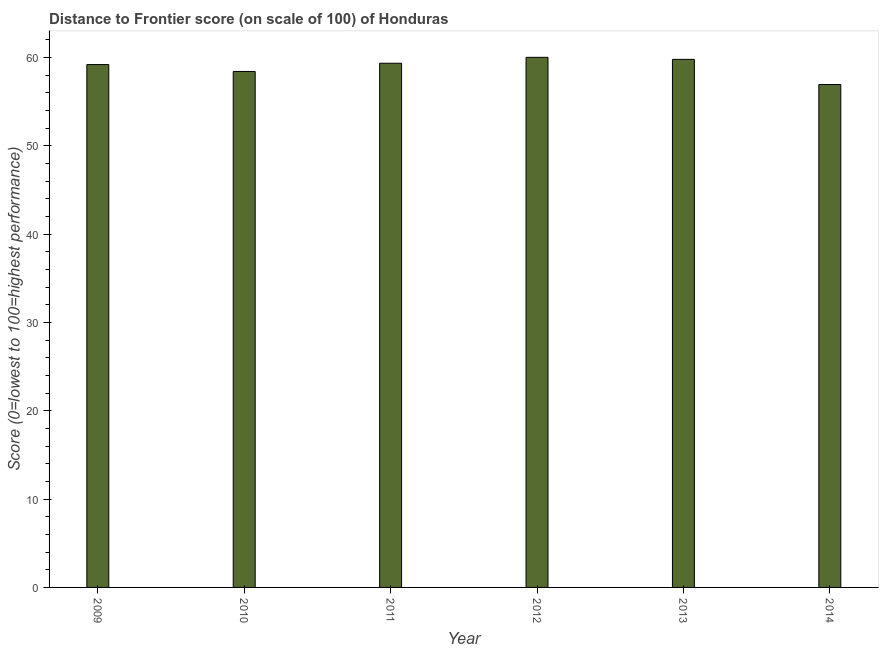Does the graph contain grids?
Your answer should be compact. No. What is the title of the graph?
Your answer should be compact. Distance to Frontier score (on scale of 100) of Honduras. What is the label or title of the Y-axis?
Your answer should be very brief. Score (0=lowest to 100=highest performance). What is the distance to frontier score in 2013?
Ensure brevity in your answer.  59.8. Across all years, what is the maximum distance to frontier score?
Your answer should be very brief. 60.03. Across all years, what is the minimum distance to frontier score?
Keep it short and to the point. 56.95. In which year was the distance to frontier score minimum?
Provide a short and direct response. 2014. What is the sum of the distance to frontier score?
Provide a succinct answer. 353.78. What is the difference between the distance to frontier score in 2009 and 2010?
Provide a short and direct response. 0.78. What is the average distance to frontier score per year?
Keep it short and to the point. 58.96. What is the median distance to frontier score?
Your answer should be compact. 59.28. In how many years, is the distance to frontier score greater than 14 ?
Keep it short and to the point. 6. Is the distance to frontier score in 2011 less than that in 2014?
Provide a succinct answer. No. What is the difference between the highest and the second highest distance to frontier score?
Your answer should be very brief. 0.23. What is the difference between the highest and the lowest distance to frontier score?
Keep it short and to the point. 3.08. How many bars are there?
Ensure brevity in your answer.  6. What is the difference between two consecutive major ticks on the Y-axis?
Keep it short and to the point. 10. Are the values on the major ticks of Y-axis written in scientific E-notation?
Give a very brief answer. No. What is the Score (0=lowest to 100=highest performance) of 2009?
Make the answer very short. 59.21. What is the Score (0=lowest to 100=highest performance) in 2010?
Offer a very short reply. 58.43. What is the Score (0=lowest to 100=highest performance) of 2011?
Keep it short and to the point. 59.36. What is the Score (0=lowest to 100=highest performance) of 2012?
Keep it short and to the point. 60.03. What is the Score (0=lowest to 100=highest performance) in 2013?
Offer a terse response. 59.8. What is the Score (0=lowest to 100=highest performance) in 2014?
Make the answer very short. 56.95. What is the difference between the Score (0=lowest to 100=highest performance) in 2009 and 2010?
Keep it short and to the point. 0.78. What is the difference between the Score (0=lowest to 100=highest performance) in 2009 and 2012?
Your answer should be compact. -0.82. What is the difference between the Score (0=lowest to 100=highest performance) in 2009 and 2013?
Your response must be concise. -0.59. What is the difference between the Score (0=lowest to 100=highest performance) in 2009 and 2014?
Offer a terse response. 2.26. What is the difference between the Score (0=lowest to 100=highest performance) in 2010 and 2011?
Your answer should be compact. -0.93. What is the difference between the Score (0=lowest to 100=highest performance) in 2010 and 2012?
Your response must be concise. -1.6. What is the difference between the Score (0=lowest to 100=highest performance) in 2010 and 2013?
Keep it short and to the point. -1.37. What is the difference between the Score (0=lowest to 100=highest performance) in 2010 and 2014?
Your response must be concise. 1.48. What is the difference between the Score (0=lowest to 100=highest performance) in 2011 and 2012?
Provide a short and direct response. -0.67. What is the difference between the Score (0=lowest to 100=highest performance) in 2011 and 2013?
Make the answer very short. -0.44. What is the difference between the Score (0=lowest to 100=highest performance) in 2011 and 2014?
Keep it short and to the point. 2.41. What is the difference between the Score (0=lowest to 100=highest performance) in 2012 and 2013?
Give a very brief answer. 0.23. What is the difference between the Score (0=lowest to 100=highest performance) in 2012 and 2014?
Offer a very short reply. 3.08. What is the difference between the Score (0=lowest to 100=highest performance) in 2013 and 2014?
Give a very brief answer. 2.85. What is the ratio of the Score (0=lowest to 100=highest performance) in 2009 to that in 2011?
Provide a succinct answer. 1. What is the ratio of the Score (0=lowest to 100=highest performance) in 2009 to that in 2012?
Your answer should be compact. 0.99. What is the ratio of the Score (0=lowest to 100=highest performance) in 2009 to that in 2014?
Make the answer very short. 1.04. What is the ratio of the Score (0=lowest to 100=highest performance) in 2010 to that in 2012?
Your answer should be very brief. 0.97. What is the ratio of the Score (0=lowest to 100=highest performance) in 2011 to that in 2014?
Give a very brief answer. 1.04. What is the ratio of the Score (0=lowest to 100=highest performance) in 2012 to that in 2013?
Keep it short and to the point. 1. What is the ratio of the Score (0=lowest to 100=highest performance) in 2012 to that in 2014?
Provide a succinct answer. 1.05. 